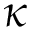Convert formula to latex. <formula><loc_0><loc_0><loc_500><loc_500>\kappa</formula> 